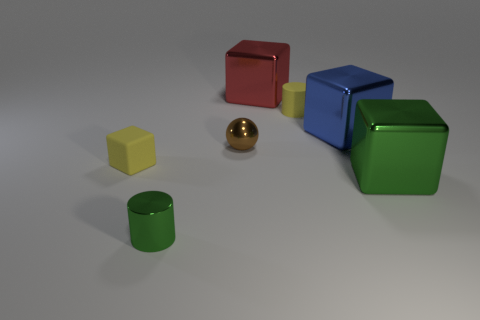Is the number of yellow objects behind the rubber cube greater than the number of small brown objects that are in front of the small green metal thing?
Make the answer very short. Yes. There is a big cube right of the blue thing; is its color the same as the metallic cylinder?
Ensure brevity in your answer.  Yes. The yellow cylinder has what size?
Ensure brevity in your answer.  Small. There is a yellow block that is the same size as the green shiny cylinder; what is it made of?
Provide a short and direct response. Rubber. There is a small matte cube to the left of the brown metallic thing; what color is it?
Offer a terse response. Yellow. How many tiny yellow shiny cubes are there?
Your answer should be very brief. 0. Are there any metallic cylinders to the left of the green object that is on the left side of the small yellow object on the right side of the green metal cylinder?
Your answer should be compact. No. What shape is the green metal thing that is the same size as the red shiny object?
Provide a succinct answer. Cube. How many other objects are there of the same color as the shiny cylinder?
Keep it short and to the point. 1. What is the yellow cylinder made of?
Ensure brevity in your answer.  Rubber. 